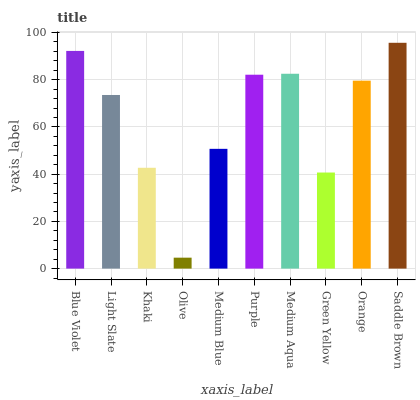Is Light Slate the minimum?
Answer yes or no. No. Is Light Slate the maximum?
Answer yes or no. No. Is Blue Violet greater than Light Slate?
Answer yes or no. Yes. Is Light Slate less than Blue Violet?
Answer yes or no. Yes. Is Light Slate greater than Blue Violet?
Answer yes or no. No. Is Blue Violet less than Light Slate?
Answer yes or no. No. Is Orange the high median?
Answer yes or no. Yes. Is Light Slate the low median?
Answer yes or no. Yes. Is Medium Blue the high median?
Answer yes or no. No. Is Saddle Brown the low median?
Answer yes or no. No. 